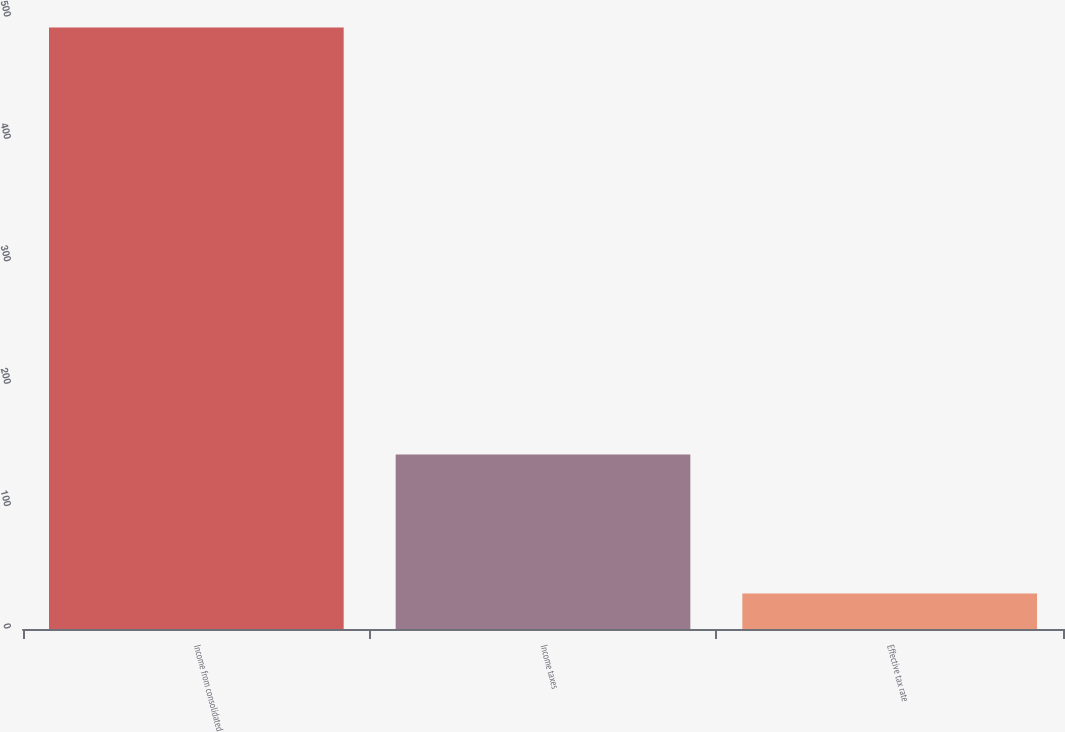<chart> <loc_0><loc_0><loc_500><loc_500><bar_chart><fcel>Income from consolidated<fcel>Income taxes<fcel>Effective tax rate<nl><fcel>491.4<fcel>142.6<fcel>29<nl></chart> 